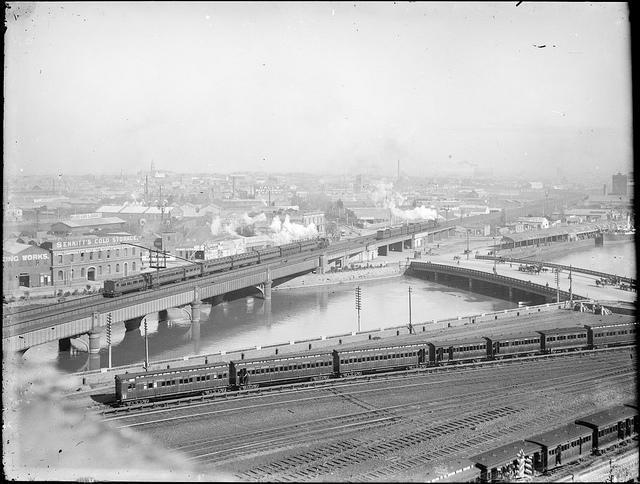How many trains can be seen?
Give a very brief answer. 3. 